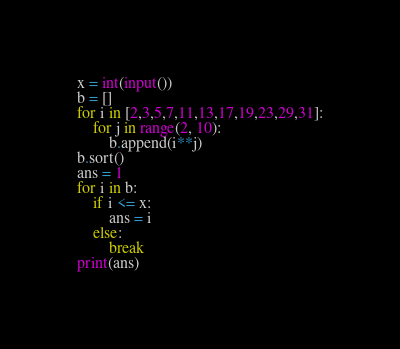Convert code to text. <code><loc_0><loc_0><loc_500><loc_500><_Python_>x = int(input())
b = []
for i in [2,3,5,7,11,13,17,19,23,29,31]:
    for j in range(2, 10):
        b.append(i**j)
b.sort()
ans = 1
for i in b:
    if i <= x:
        ans = i
    else:
        break
print(ans)</code> 